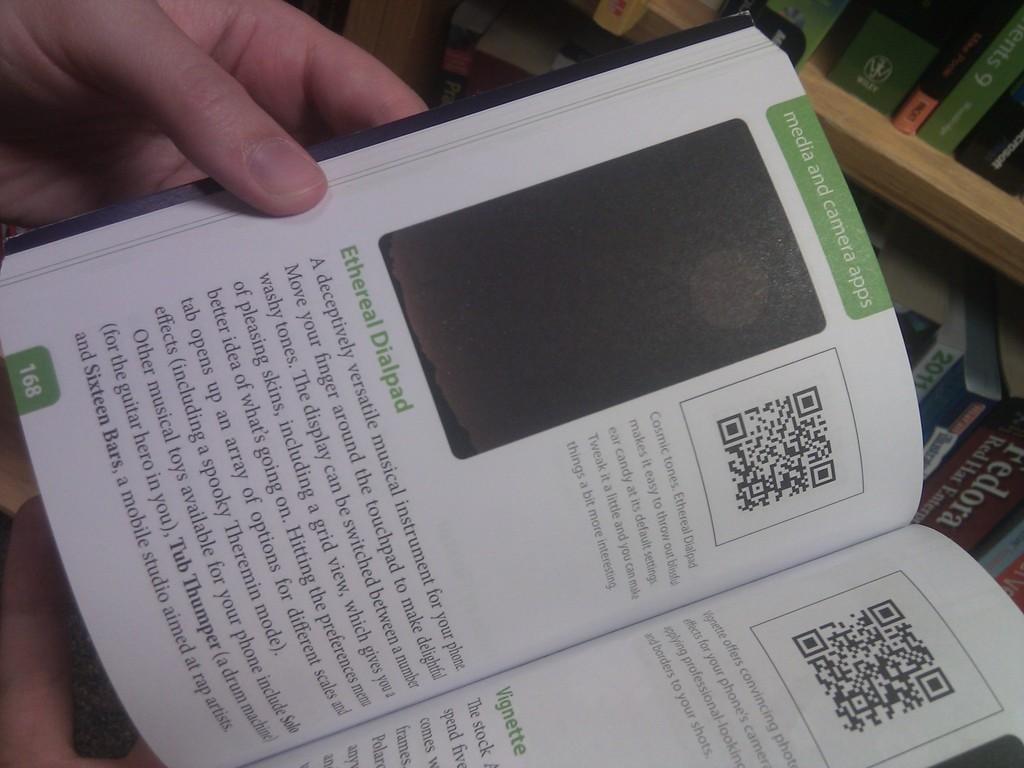<image>
Relay a brief, clear account of the picture shown. A book is opened to a page titled "media and camera apps." 